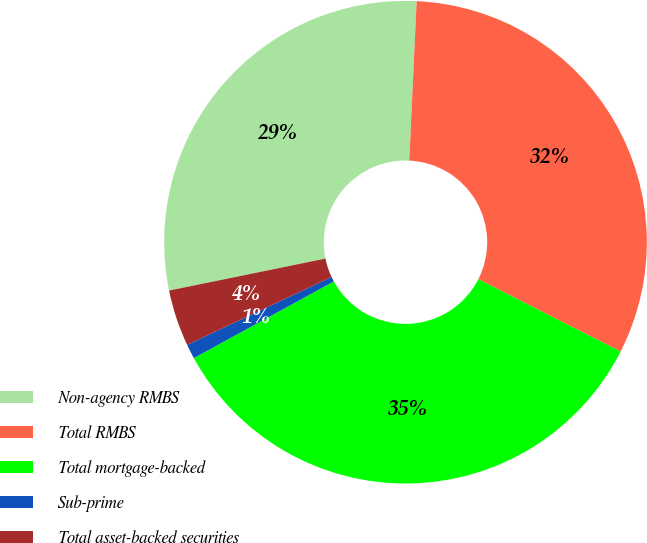Convert chart. <chart><loc_0><loc_0><loc_500><loc_500><pie_chart><fcel>Non-agency RMBS<fcel>Total RMBS<fcel>Total mortgage-backed<fcel>Sub-prime<fcel>Total asset-backed securities<nl><fcel>28.95%<fcel>31.75%<fcel>34.54%<fcel>0.98%<fcel>3.78%<nl></chart> 